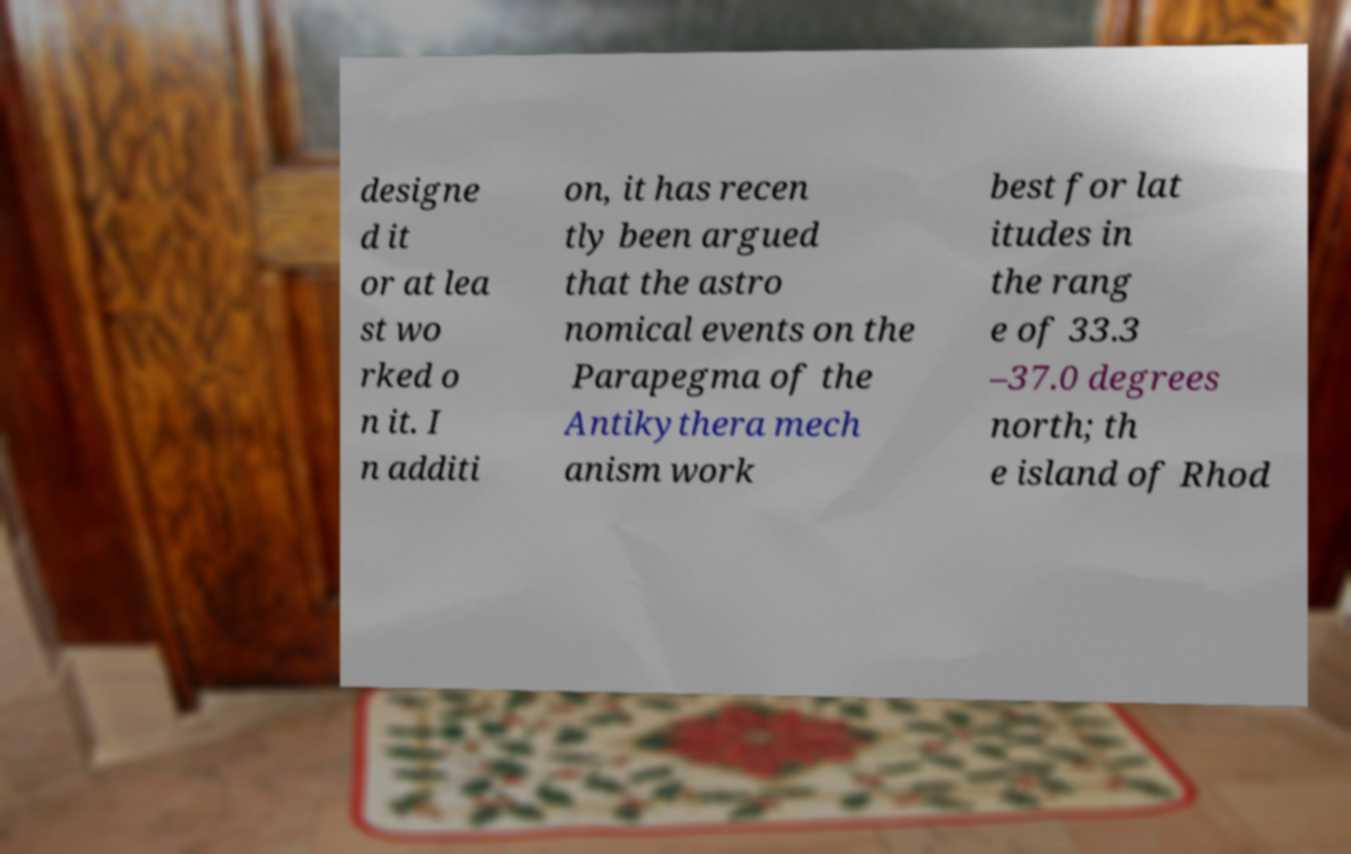For documentation purposes, I need the text within this image transcribed. Could you provide that? designe d it or at lea st wo rked o n it. I n additi on, it has recen tly been argued that the astro nomical events on the Parapegma of the Antikythera mech anism work best for lat itudes in the rang e of 33.3 –37.0 degrees north; th e island of Rhod 